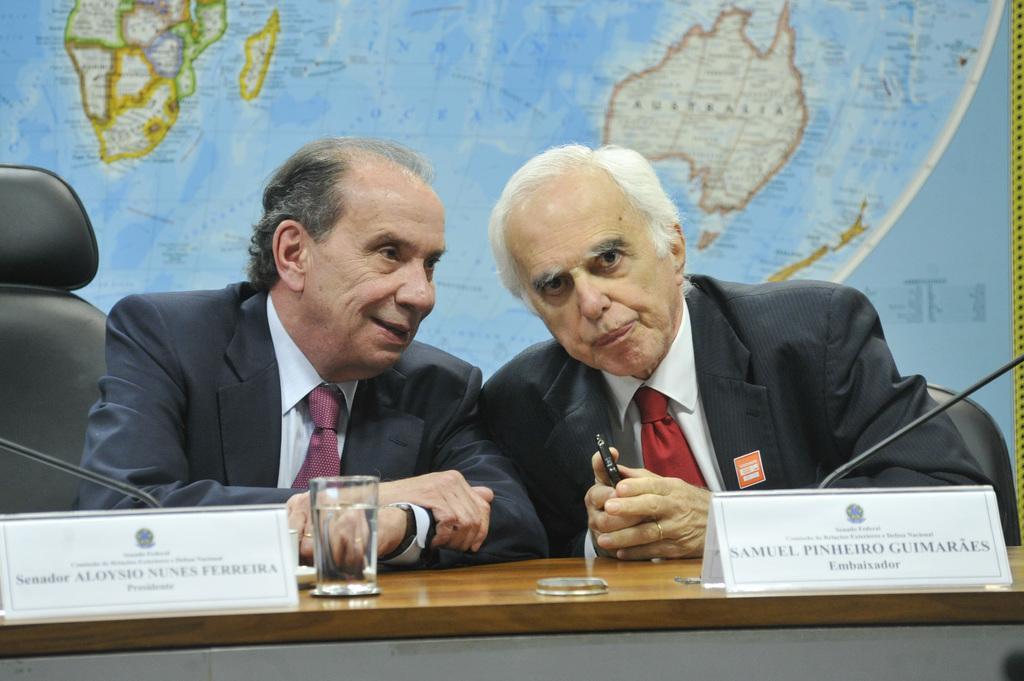Describe this image in one or two sentences. In this picture I can see there are two people sitting here and they are wearing blazers and the man on too left is smiling and there is a table in front of them. There is a map in the backdrop. 